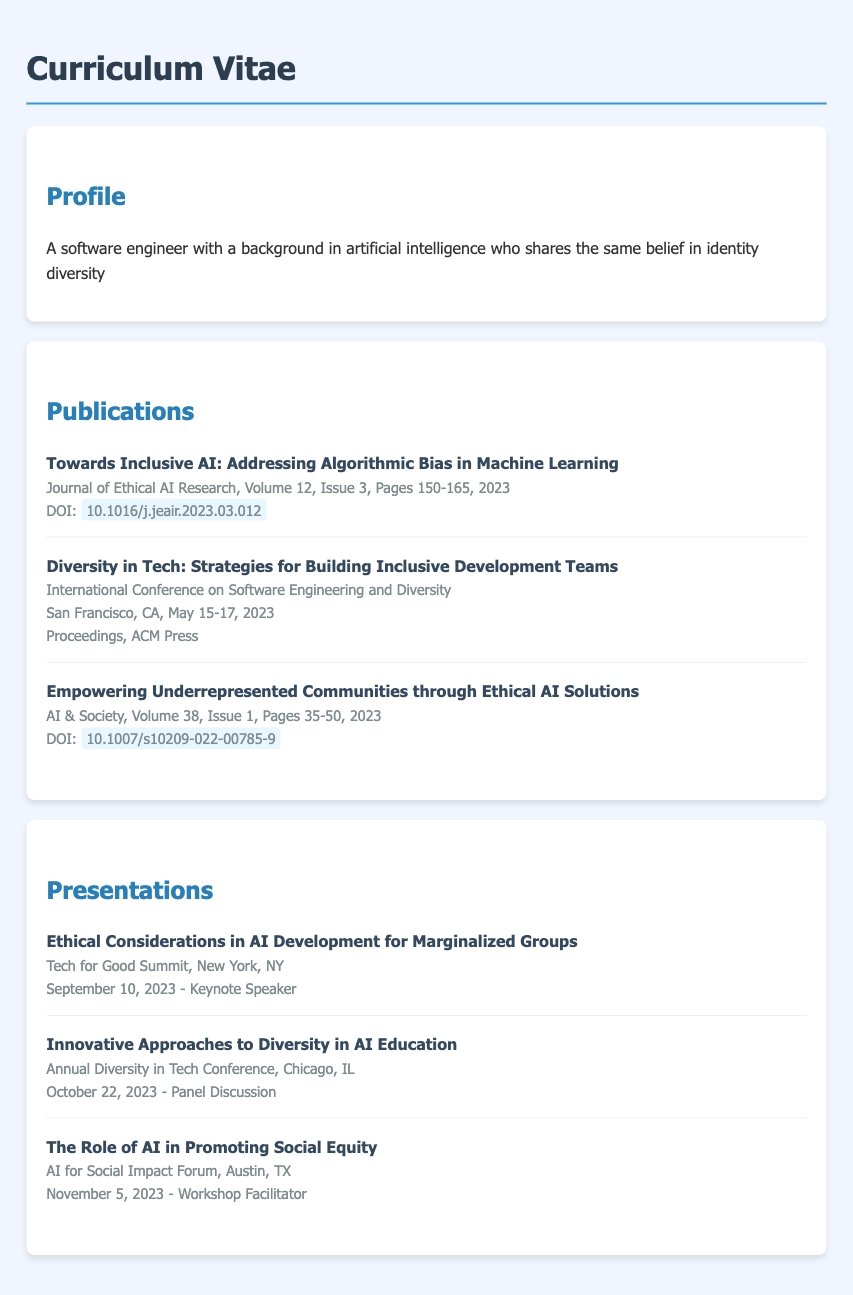what is the title of the publication on algorithmic bias? The title is explicitly mentioned in the publications section.
Answer: Towards Inclusive AI: Addressing Algorithmic Bias in Machine Learning when was the International Conference on Software Engineering and Diversity held? The specific date is listed alongside the events under publications.
Answer: May 15-17, 2023 how many pages does the article "Empowering Underrepresented Communities through Ethical AI Solutions" have? The page range is provided in the details of the publication.
Answer: Pages 35-50 who was the keynote speaker at the Tech for Good Summit? The document notes the participant designation for the presentation, implying their role.
Answer: Keynote Speaker which journal published the research on ethical AI solutions? The name of the journal is explicitly provided in the publication details.
Answer: AI & Society what is the focus of the panel discussion at the Annual Diversity in Tech Conference? The title of the presentation outlines the subject of focus at the conference.
Answer: Innovative Approaches to Diversity in AI Education how many presentations are listed in the document? The number of listed presentations can be counted.
Answer: Three what is the document type of this content? The structure and purpose of the content clearly define its classification.
Answer: Curriculum Vitae 